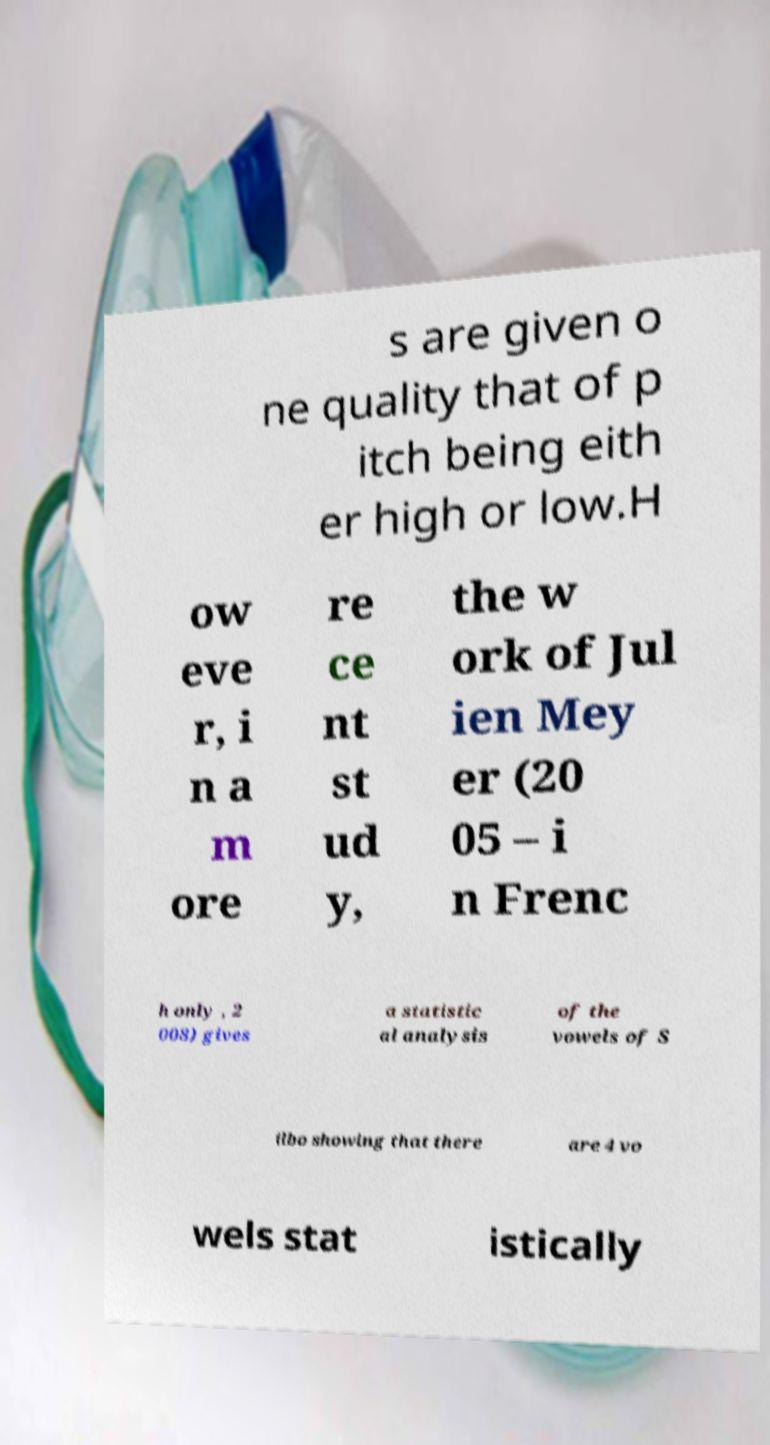Please read and relay the text visible in this image. What does it say? s are given o ne quality that of p itch being eith er high or low.H ow eve r, i n a m ore re ce nt st ud y, the w ork of Jul ien Mey er (20 05 – i n Frenc h only , 2 008) gives a statistic al analysis of the vowels of S ilbo showing that there are 4 vo wels stat istically 